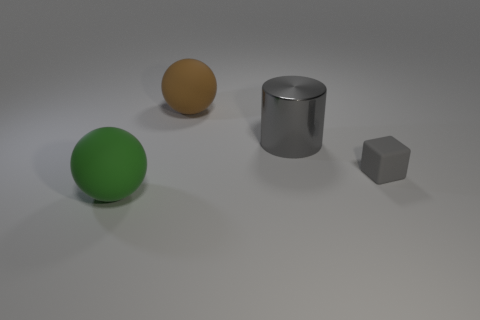Add 2 big rubber spheres. How many objects exist? 6 Subtract all cylinders. How many objects are left? 3 Add 3 large brown matte things. How many large brown matte things exist? 4 Subtract 0 purple balls. How many objects are left? 4 Subtract all big brown cylinders. Subtract all brown things. How many objects are left? 3 Add 4 big brown objects. How many big brown objects are left? 5 